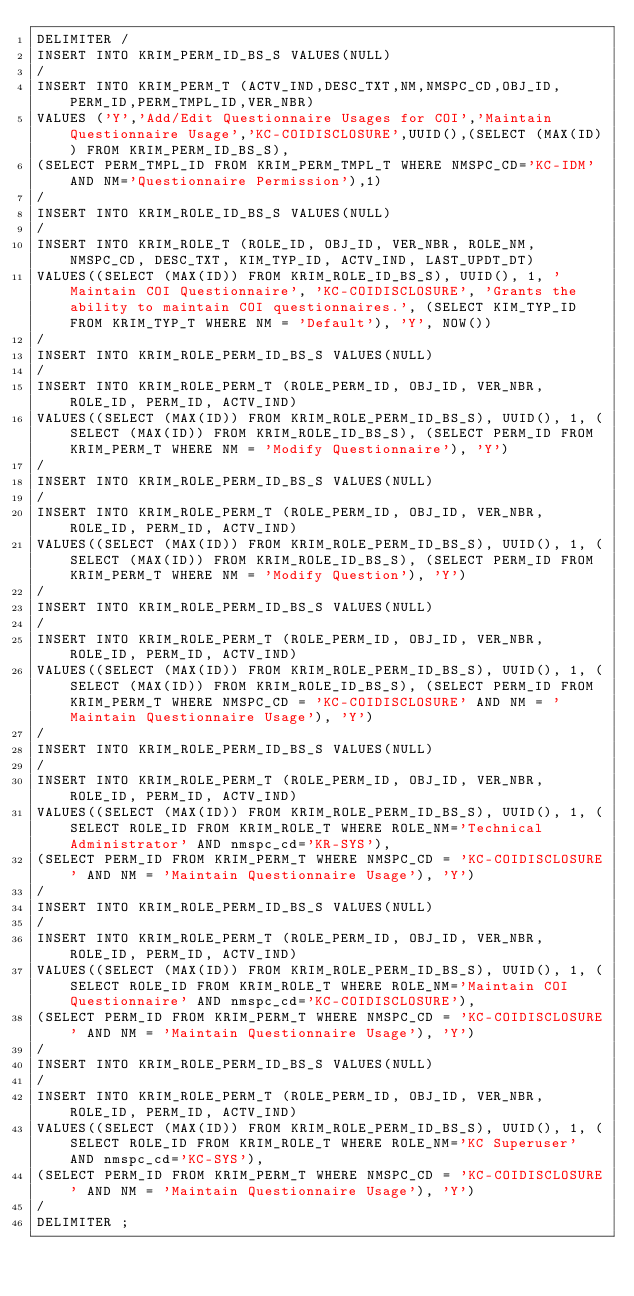<code> <loc_0><loc_0><loc_500><loc_500><_SQL_>DELIMITER /
INSERT INTO KRIM_PERM_ID_BS_S VALUES(NULL)
/
INSERT INTO KRIM_PERM_T (ACTV_IND,DESC_TXT,NM,NMSPC_CD,OBJ_ID,PERM_ID,PERM_TMPL_ID,VER_NBR)
VALUES ('Y','Add/Edit Questionnaire Usages for COI','Maintain Questionnaire Usage','KC-COIDISCLOSURE',UUID(),(SELECT (MAX(ID)) FROM KRIM_PERM_ID_BS_S),
(SELECT PERM_TMPL_ID FROM KRIM_PERM_TMPL_T WHERE NMSPC_CD='KC-IDM' AND NM='Questionnaire Permission'),1)
/
INSERT INTO KRIM_ROLE_ID_BS_S VALUES(NULL)
/
INSERT INTO KRIM_ROLE_T (ROLE_ID, OBJ_ID, VER_NBR, ROLE_NM, NMSPC_CD, DESC_TXT, KIM_TYP_ID, ACTV_IND, LAST_UPDT_DT)
VALUES((SELECT (MAX(ID)) FROM KRIM_ROLE_ID_BS_S), UUID(), 1, 'Maintain COI Questionnaire', 'KC-COIDISCLOSURE', 'Grants the ability to maintain COI questionnaires.', (SELECT KIM_TYP_ID FROM KRIM_TYP_T WHERE NM = 'Default'), 'Y', NOW())
/
INSERT INTO KRIM_ROLE_PERM_ID_BS_S VALUES(NULL)
/
INSERT INTO KRIM_ROLE_PERM_T (ROLE_PERM_ID, OBJ_ID, VER_NBR, ROLE_ID, PERM_ID, ACTV_IND)
VALUES((SELECT (MAX(ID)) FROM KRIM_ROLE_PERM_ID_BS_S), UUID(), 1, (SELECT (MAX(ID)) FROM KRIM_ROLE_ID_BS_S), (SELECT PERM_ID FROM KRIM_PERM_T WHERE NM = 'Modify Questionnaire'), 'Y')
/
INSERT INTO KRIM_ROLE_PERM_ID_BS_S VALUES(NULL)
/
INSERT INTO KRIM_ROLE_PERM_T (ROLE_PERM_ID, OBJ_ID, VER_NBR, ROLE_ID, PERM_ID, ACTV_IND)
VALUES((SELECT (MAX(ID)) FROM KRIM_ROLE_PERM_ID_BS_S), UUID(), 1, (SELECT (MAX(ID)) FROM KRIM_ROLE_ID_BS_S), (SELECT PERM_ID FROM KRIM_PERM_T WHERE NM = 'Modify Question'), 'Y')
/
INSERT INTO KRIM_ROLE_PERM_ID_BS_S VALUES(NULL)
/
INSERT INTO KRIM_ROLE_PERM_T (ROLE_PERM_ID, OBJ_ID, VER_NBR, ROLE_ID, PERM_ID, ACTV_IND)
VALUES((SELECT (MAX(ID)) FROM KRIM_ROLE_PERM_ID_BS_S), UUID(), 1, (SELECT (MAX(ID)) FROM KRIM_ROLE_ID_BS_S), (SELECT PERM_ID FROM KRIM_PERM_T WHERE NMSPC_CD = 'KC-COIDISCLOSURE' AND NM = 'Maintain Questionnaire Usage'), 'Y')
/
INSERT INTO KRIM_ROLE_PERM_ID_BS_S VALUES(NULL)
/
INSERT INTO KRIM_ROLE_PERM_T (ROLE_PERM_ID, OBJ_ID, VER_NBR, ROLE_ID, PERM_ID, ACTV_IND)
VALUES((SELECT (MAX(ID)) FROM KRIM_ROLE_PERM_ID_BS_S), UUID(), 1, (SELECT ROLE_ID FROM KRIM_ROLE_T WHERE ROLE_NM='Technical Administrator' AND nmspc_cd='KR-SYS'),
(SELECT PERM_ID FROM KRIM_PERM_T WHERE NMSPC_CD = 'KC-COIDISCLOSURE' AND NM = 'Maintain Questionnaire Usage'), 'Y')
/
INSERT INTO KRIM_ROLE_PERM_ID_BS_S VALUES(NULL)
/
INSERT INTO KRIM_ROLE_PERM_T (ROLE_PERM_ID, OBJ_ID, VER_NBR, ROLE_ID, PERM_ID, ACTV_IND)
VALUES((SELECT (MAX(ID)) FROM KRIM_ROLE_PERM_ID_BS_S), UUID(), 1, (SELECT ROLE_ID FROM KRIM_ROLE_T WHERE ROLE_NM='Maintain COI Questionnaire' AND nmspc_cd='KC-COIDISCLOSURE'),
(SELECT PERM_ID FROM KRIM_PERM_T WHERE NMSPC_CD = 'KC-COIDISCLOSURE' AND NM = 'Maintain Questionnaire Usage'), 'Y')
/
INSERT INTO KRIM_ROLE_PERM_ID_BS_S VALUES(NULL)
/
INSERT INTO KRIM_ROLE_PERM_T (ROLE_PERM_ID, OBJ_ID, VER_NBR, ROLE_ID, PERM_ID, ACTV_IND)
VALUES((SELECT (MAX(ID)) FROM KRIM_ROLE_PERM_ID_BS_S), UUID(), 1, (SELECT ROLE_ID FROM KRIM_ROLE_T WHERE ROLE_NM='KC Superuser' AND nmspc_cd='KC-SYS'),
(SELECT PERM_ID FROM KRIM_PERM_T WHERE NMSPC_CD = 'KC-COIDISCLOSURE' AND NM = 'Maintain Questionnaire Usage'), 'Y')
/
DELIMITER ;
</code> 